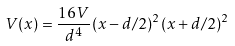Convert formula to latex. <formula><loc_0><loc_0><loc_500><loc_500>V ( x ) = \frac { 1 6 V } { d ^ { 4 } } ( x - d / 2 ) ^ { 2 } ( x + d / 2 ) ^ { 2 }</formula> 